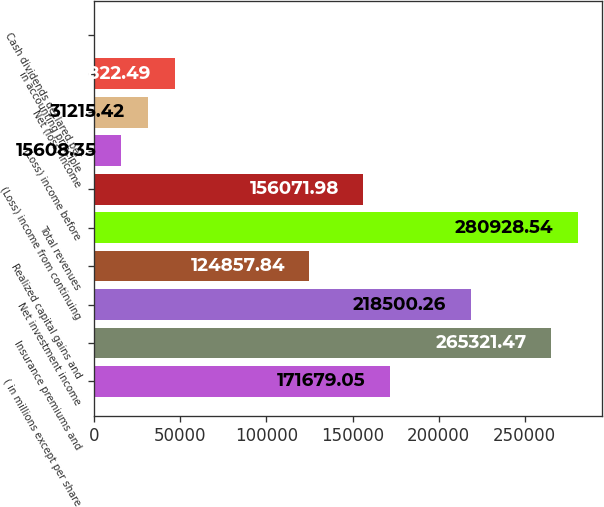Convert chart. <chart><loc_0><loc_0><loc_500><loc_500><bar_chart><fcel>( in millions except per share<fcel>Insurance premiums and<fcel>Net investment income<fcel>Realized capital gains and<fcel>Total revenues<fcel>(Loss) income from continuing<fcel>(Loss) income before<fcel>Net (loss) income<fcel>in accounting principle<fcel>Cash dividends declared per<nl><fcel>171679<fcel>265321<fcel>218500<fcel>124858<fcel>280929<fcel>156072<fcel>15608.4<fcel>31215.4<fcel>46822.5<fcel>1.28<nl></chart> 